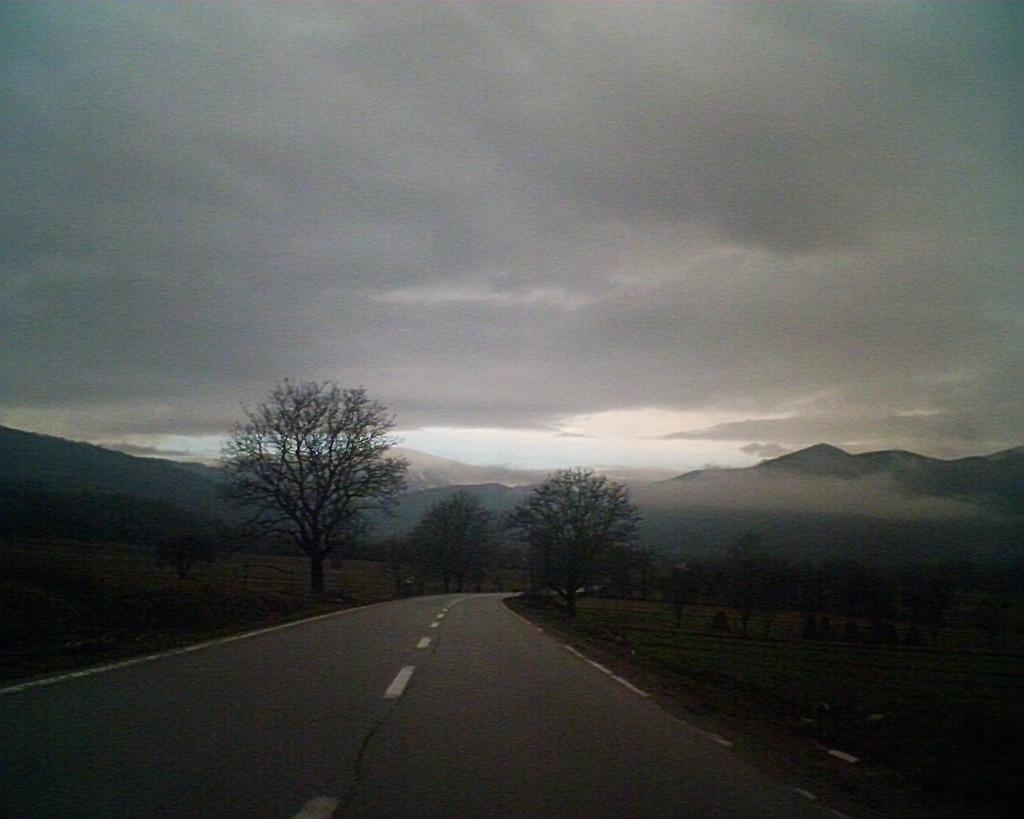What is located at the bottom of the image? There is a road at the bottom of the image. What can be seen on either side of the road? Trees and grass are visible on either side of the road. What is in the background of the image? There are hills in the background of the image. What is visible at the top of the image? The sky is visible at the top of the image. What type of chalk is being used to draw on the road in the image? There is no chalk or drawing present in the image; it features a road with trees, grass, hills, and sky. How many knots are tied in the trees on either side of the road? There are no knots present in the trees or anywhere else in the image. 